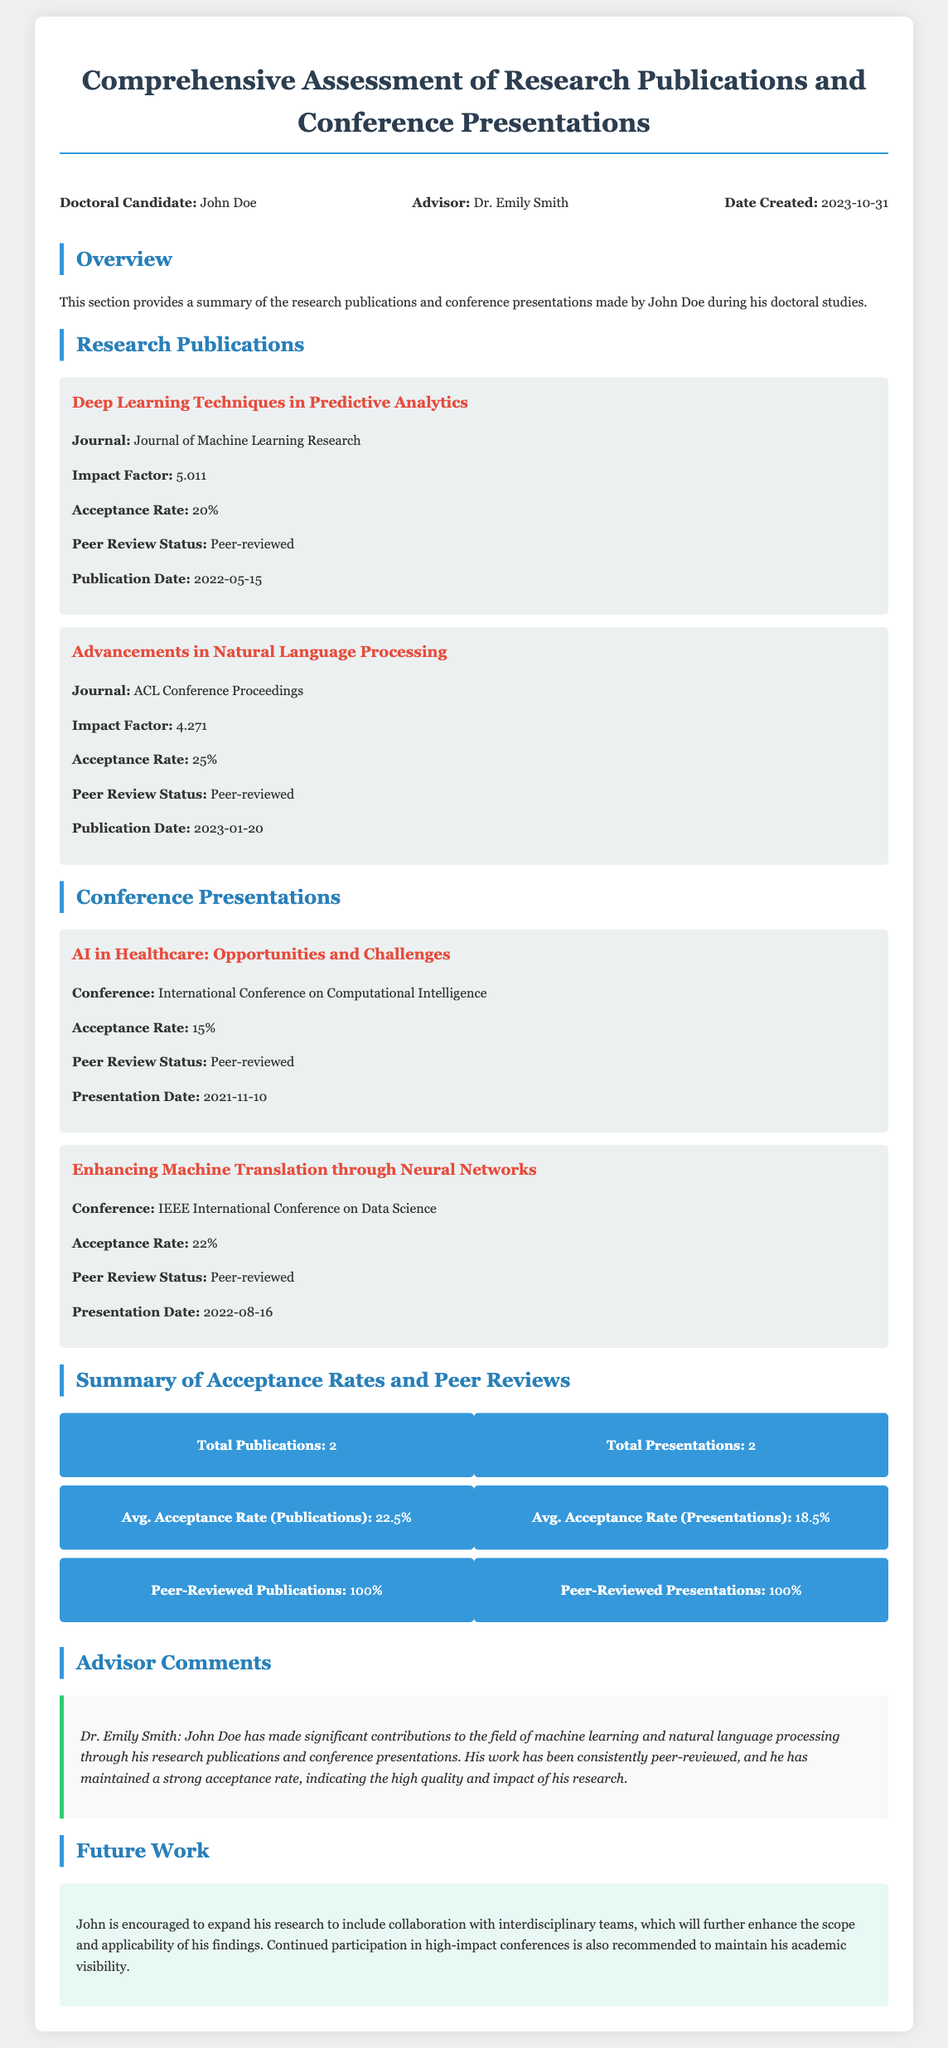What is the total number of publications? The total number of publications is indicated in the summary of statistics at the bottom of the document.
Answer: 2 What is the acceptance rate for the publication "Deep Learning Techniques in Predictive Analytics"? The acceptance rate for this publication is specified in the publication details.
Answer: 20% Who is the advisor for John Doe? The advisor's name is mentioned in the info section at the top of the document.
Answer: Dr. Emily Smith What is the impact factor of the journal "ACL Conference Proceedings"? The impact factor is included in the publication details of the document.
Answer: 4.271 What is the average acceptance rate for presentations? The average acceptance rate for presentations can be found in the summary statistics at the end of the document.
Answer: 18.5% In what year was the presentation on "AI in Healthcare: Opportunities and Challenges" made? The year of the presentation is provided in the presentation details section.
Answer: 2021 Which conference featured the presentation "Enhancing Machine Translation through Neural Networks"? This information can be retrieved from the specific details of the presentation section.
Answer: IEEE International Conference on Data Science What percentage of publications are peer-reviewed? The percentage of peer-reviewed publications is summarized in the statistics section.
Answer: 100% What future work is suggested for John Doe? The future work recommendations are described in the last section of the document.
Answer: Collaborate with interdisciplinary teams 